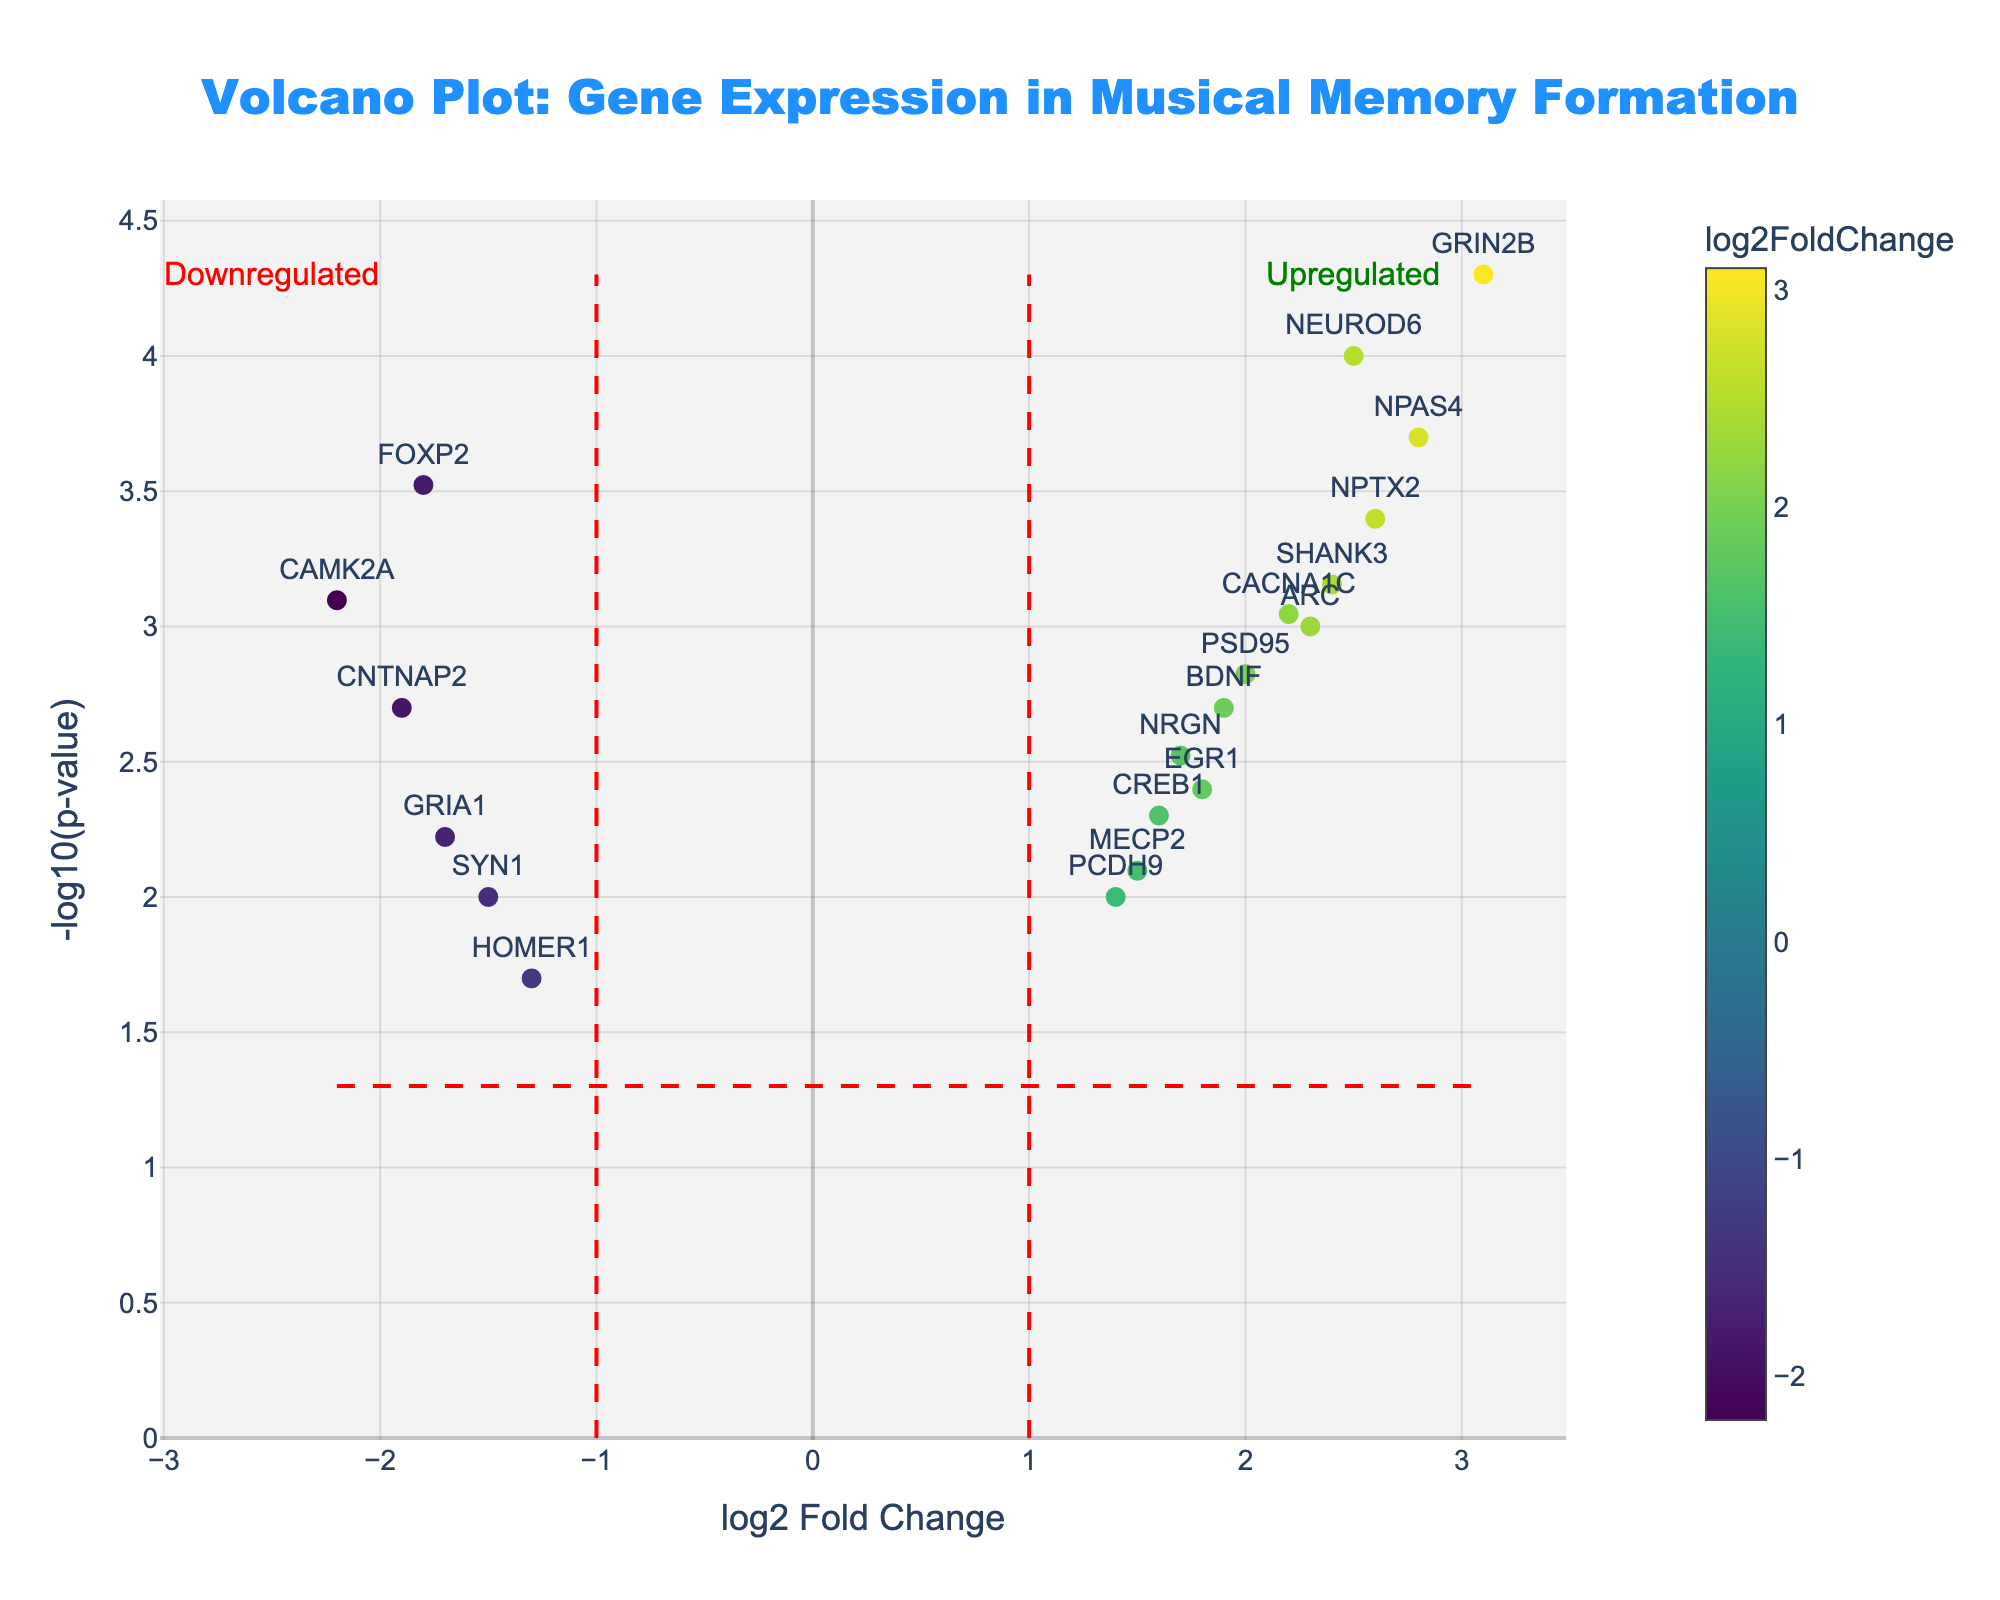Which gene has the highest -log10(p-value) and what is its value? The gene with the highest -log10(p-value) can be found by identifying the data point with the maximum y-value. In this plot, GRIN2B has the highest -log10(p-value) value of 4.3010.
Answer: GRIN2B, 4.3010 What is the log2 Fold Change of FOXP2? To find this, locate the data point labeled "FOXP2" and check its position on the x-axis. FOXP2 is positioned at -1.8 on the x-axis.
Answer: -1.8 How many genes are significantly upregulated? Upregulated genes have log2 Fold Change > 1 and -log10(p-value) values above the threshold line. Counting the markers above the p-value threshold and to the right of the vertical line at a log2 Fold Change of 1, we find 7 such genes: NEUROD6, GRIN2B, BDNF, NPAS4, ARC, NPTX2, SHANK3.
Answer: 7 Which gene is represented by the data point at the highest positive log2 Fold Change? To determine this, identify the data point furthest to the right on the plot. GRIN2B represents the highest positive log2 Fold Change at 3.1.
Answer: GRIN2B How many genes are downregulated with statistically significant p-values? Downregulated genes have log2 Fold Change < -1 and -log10(p-value) values above the threshold line. Counting the markers fitting these criteria, we find 3 such genes: FOXP2, CAMK2A, CNTNAP2.
Answer: 3 What is the horizontal line at -log10(p-value) representing? The horizontal line represents the p-value significance threshold, commonly set at p = 0.05. The position of this line can be found by calculating -log10(0.05), which is 1.3010.
Answer: p-value threshold of 0.05 Compare the log2 Fold Changes of NEUROD6 and CREB1. Which one is higher? To compare, check the x-axis positions of NEUROD6 and CREB1. NEUROD6 is at 2.5 while CREB1 is at 1.6. Thus, the log2 Fold Change of NEUROD6 is higher than CREB1.
Answer: NEUROD6 What is the p-value of SYN1 and how does it compare to the significance threshold? The p-value can be found by looking at the y-axis value of SYN1 and converting from -log10. SYN1 is at 2 on the x-axis but at a log2 Fold Change of -1.5 and p-value 0.01. Since -log10(0.01) is 2, SYN1 is above the significance threshold.
Answer: 0.01; significant Which genes show statistically significant downregulation? Statistically significant downregulation can be deduced by looking for genes with log2 Fold Change < -1 and -log10(p-value) > 1.301. The genes are FOXP2, CAMK2A, and CNTNAP2.
Answer: FOXP2, CAMK2A, CNTNAP2 